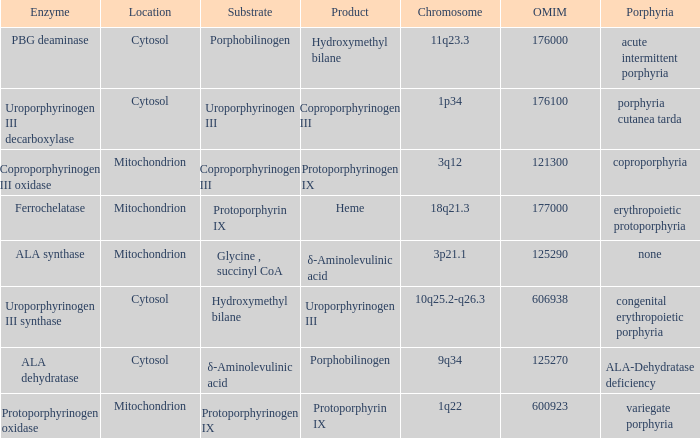Which substrate has an OMIM of 176000? Porphobilinogen. 